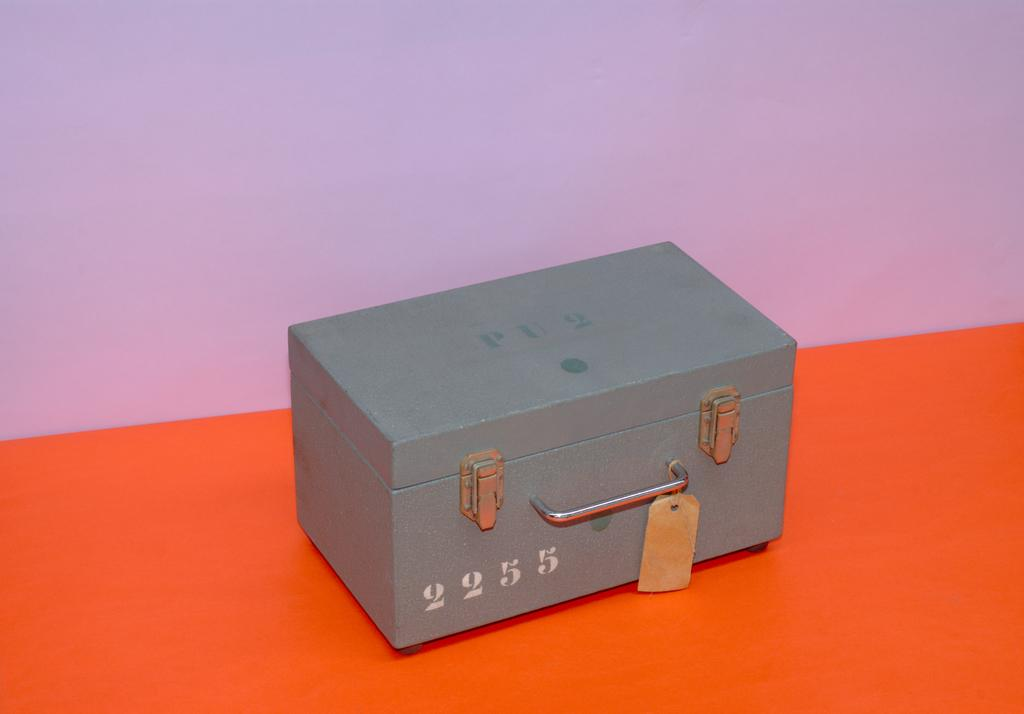Provide a one-sentence caption for the provided image. A metal box has the number 2255 written in white on its front. 